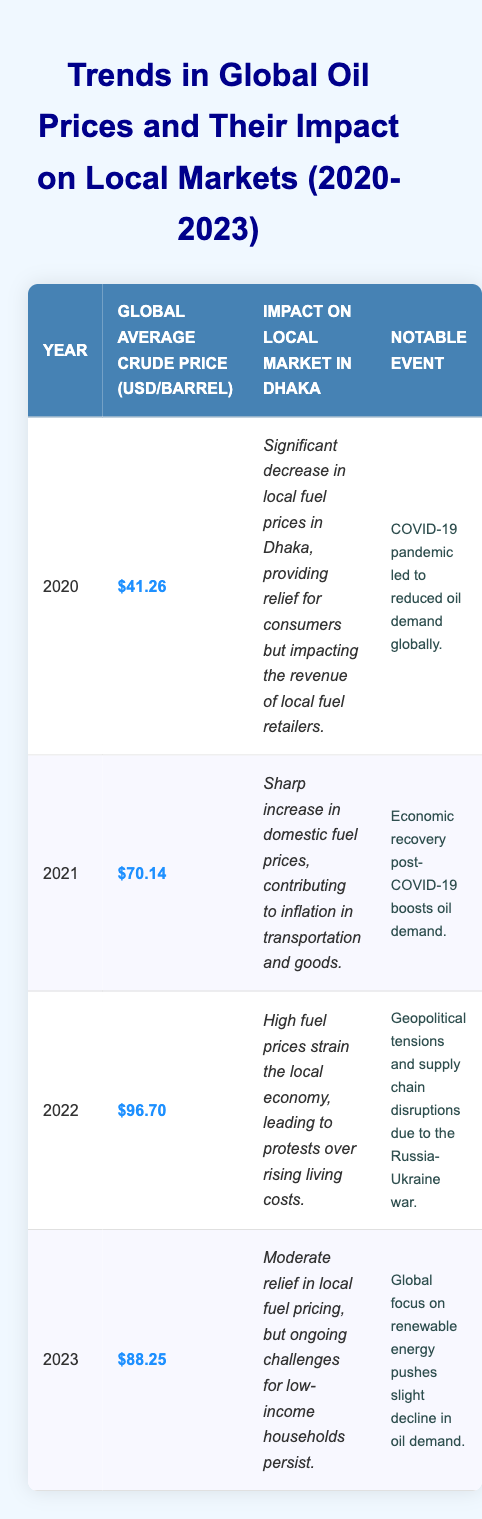What was the global average crude price per barrel in 2020? Referring to the table, the global average crude price for the year 2020 is listed as $41.26.
Answer: $41.26 Which year had the highest global average crude price? In the table, the global average prices are $41.26 (2020), $70.14 (2021), $96.70 (2022), and $88.25 (2023). The highest is $96.70 in 2022.
Answer: 2022 What impact did the crude price increase in 2021 have on the local market in Dhaka? The impact in 2021 was described as a sharp increase in domestic fuel prices, which contributed to inflation in transportation and goods.
Answer: Sharp increase in domestic fuel prices, contributing to inflation Was there a notable event linked to the increase in oil prices in 2021? Yes, the economic recovery post-COVID-19 is noted as a significant event that boosted oil demand in 2021.
Answer: Yes What was the average global crude price for the years 2020 to 2023? To find the average: ($41.26 + $70.14 + $96.70 + $88.25) = $296.35; dividing by 4 gives $74.09.
Answer: $74.09 Was there a significant decrease in local fuel prices in Dhaka in 2020? Yes, the data states there was a significant decrease in local fuel prices in Dhaka during 2020 that provided relief for consumers.
Answer: Yes How did the events in 2022 affect local markets compared to 2020? In 2022, high fuel prices strained the local economy leading to protests, while in 2020, there was a significant decrease in prices that helped consumers. Thus, 2022 was negatively impactful compared to the relief in 2020.
Answer: 2022 had a negative impact, while 2020 had a positive impact If oil prices decreased from 2022 to 2023, what was the amount of decrease in global average crude price per barrel? The price dropped from $96.70 in 2022 to $88.25 in 2023. The difference is $96.70 - $88.25 = $8.45.
Answer: $8.45 Did low-income households face challenges in 2023 despite a slight decline in local fuel pricing? Yes, the data indicates that despite moderate relief in local fuel pricing in 2023, ongoing challenges for low-income households persist.
Answer: Yes What were the notable events impacting the oil prices from 2020 to 2023? The notable events are: 2020 - COVID-19 pandemic; 2021 - Economic recovery; 2022 - Geopolitical tensions; 2023 - Global focus on renewable energy.
Answer: COVID-19, Economic recovery, Geopolitical tensions, Renewable energy focus Based on the data, which year had the highest reported social tension in Dhaka due to fuel prices? The year with the highest reported social tension was 2022, when high fuel prices led to protests over rising living costs in Dhaka.
Answer: 2022 